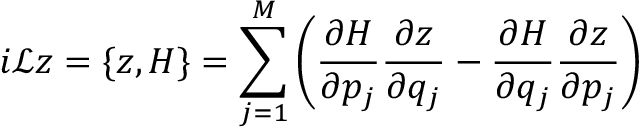<formula> <loc_0><loc_0><loc_500><loc_500>i \mathcal { L } z = \{ z , H \} = \sum _ { j = 1 } ^ { M } \left ( \frac { \partial H } { \partial p _ { j } } \frac { \partial z } { \partial q _ { j } } - \frac { \partial H } { \partial q _ { j } } \frac { \partial z } { \partial p _ { j } } \right )</formula> 